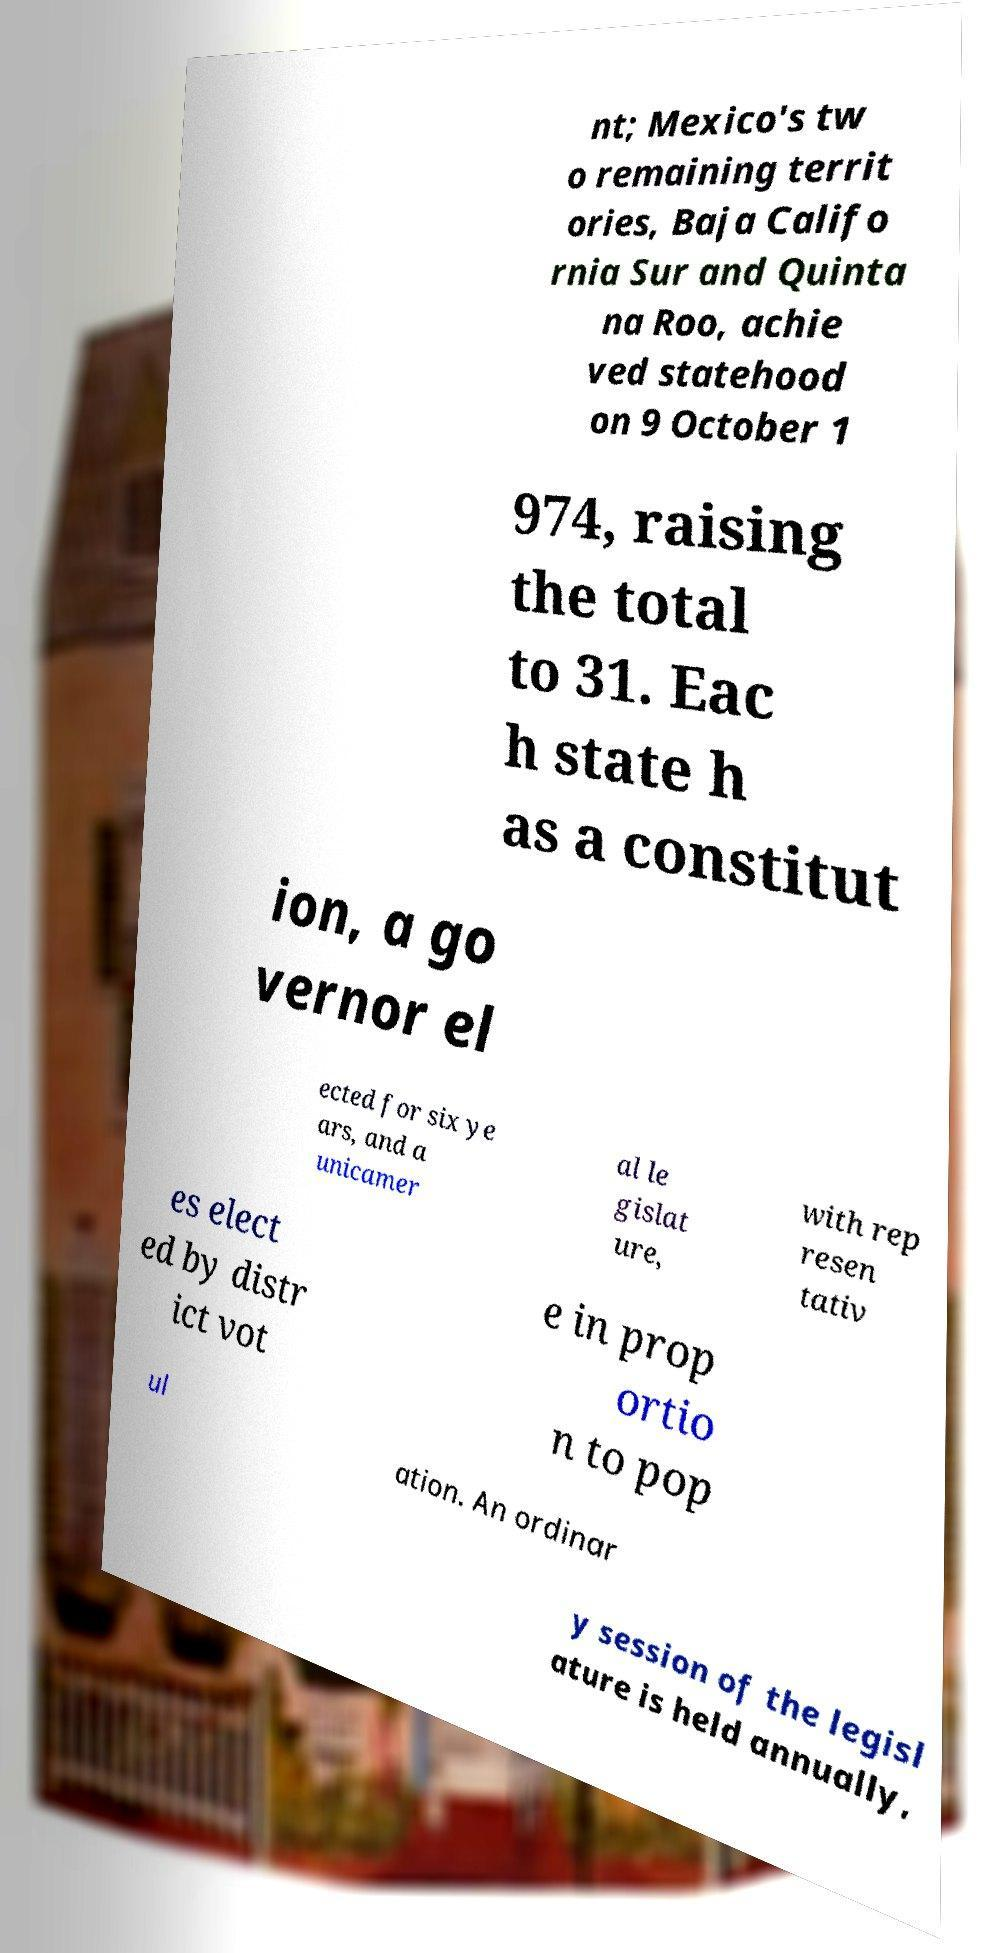What messages or text are displayed in this image? I need them in a readable, typed format. nt; Mexico's tw o remaining territ ories, Baja Califo rnia Sur and Quinta na Roo, achie ved statehood on 9 October 1 974, raising the total to 31. Eac h state h as a constitut ion, a go vernor el ected for six ye ars, and a unicamer al le gislat ure, with rep resen tativ es elect ed by distr ict vot e in prop ortio n to pop ul ation. An ordinar y session of the legisl ature is held annually, 